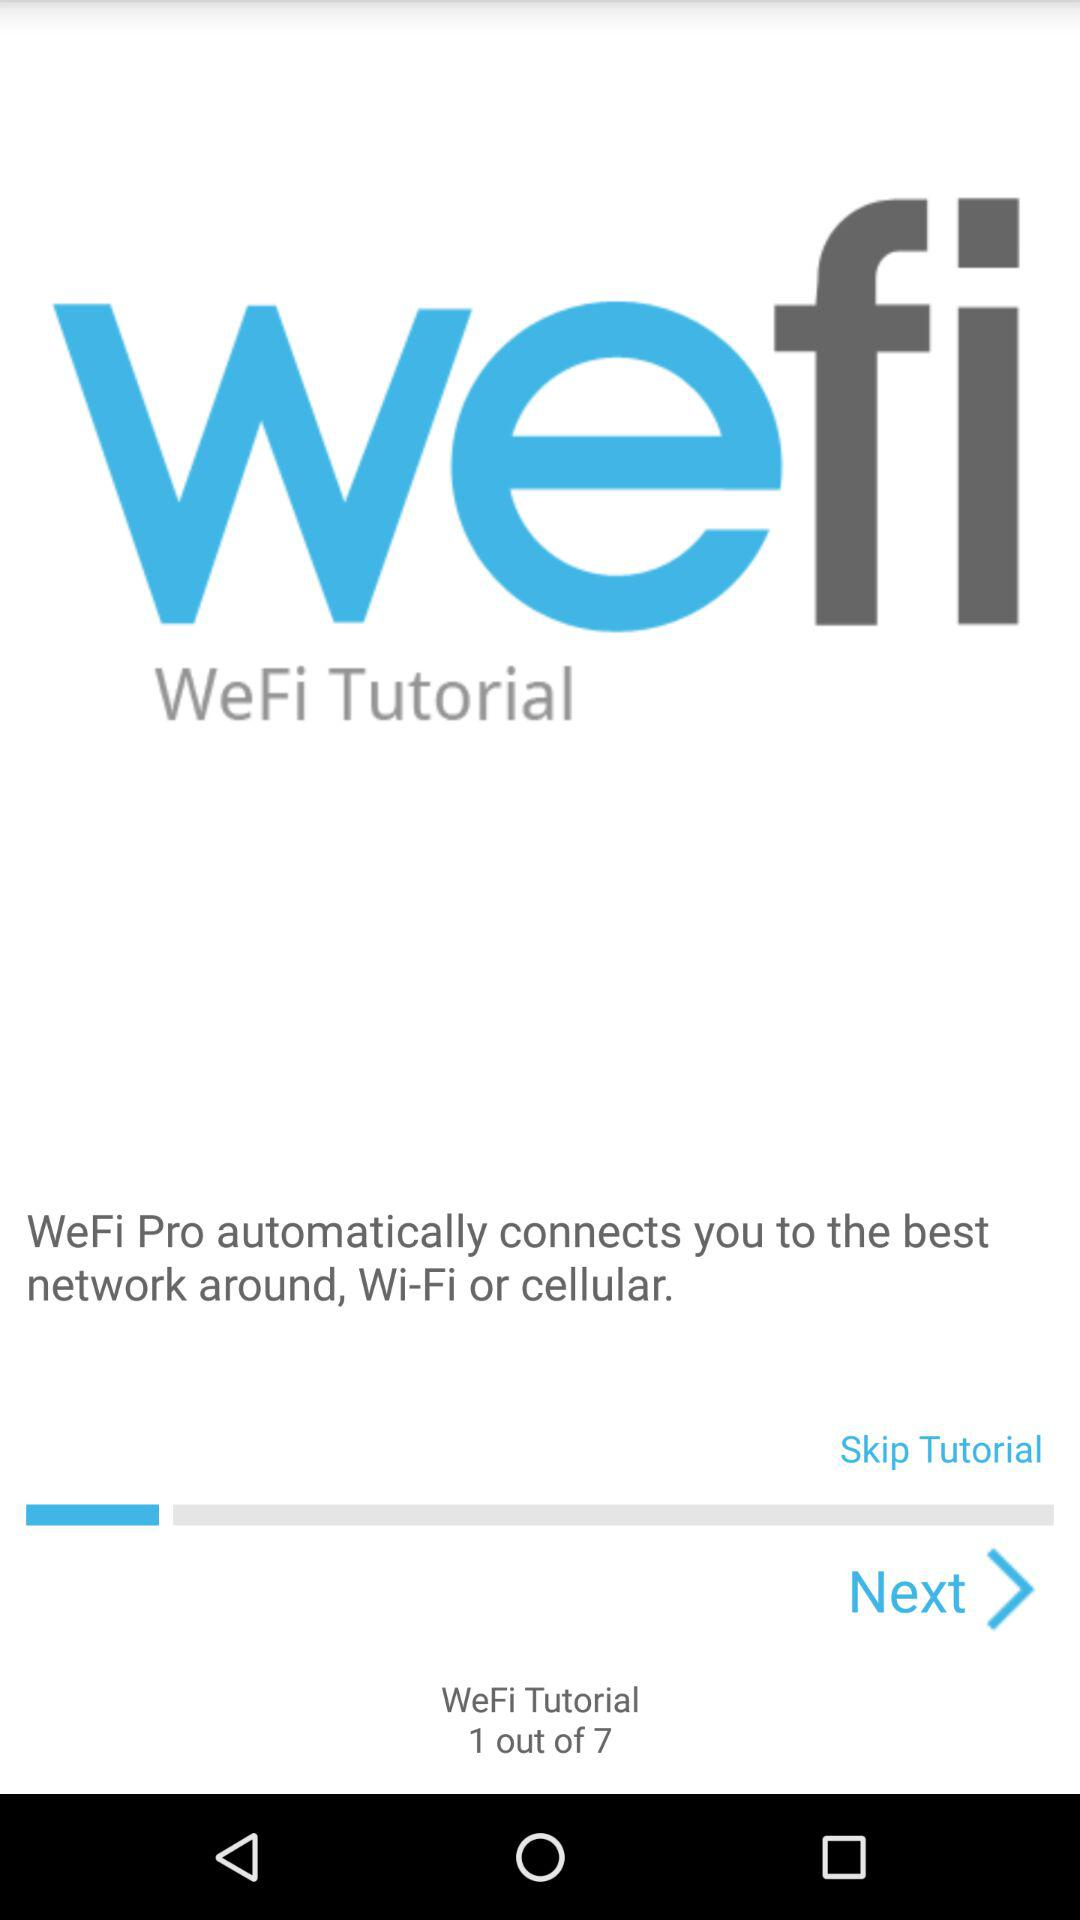What is the name of the application? The name of the application is "WeFi Pro". 